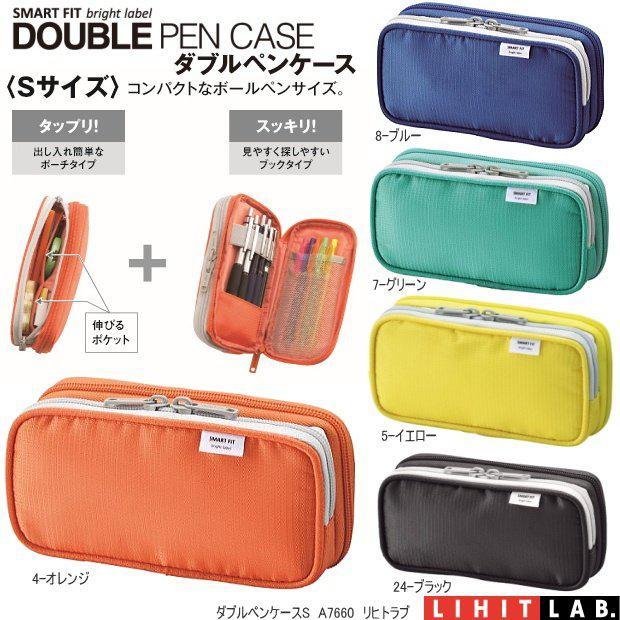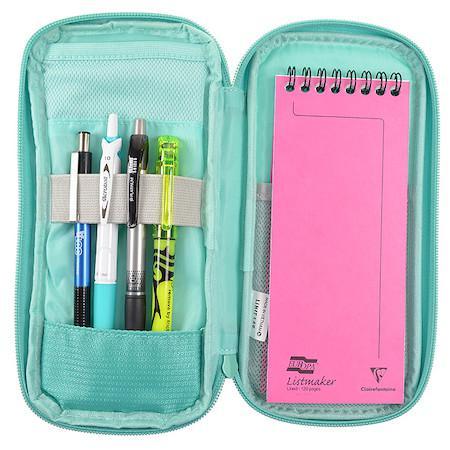The first image is the image on the left, the second image is the image on the right. Considering the images on both sides, is "Each image includes a single pencil case, and the left image shows an open case filled with writing implements." valid? Answer yes or no. No. The first image is the image on the left, the second image is the image on the right. Evaluate the accuracy of this statement regarding the images: "There is one yellow and one black case.". Is it true? Answer yes or no. Yes. 